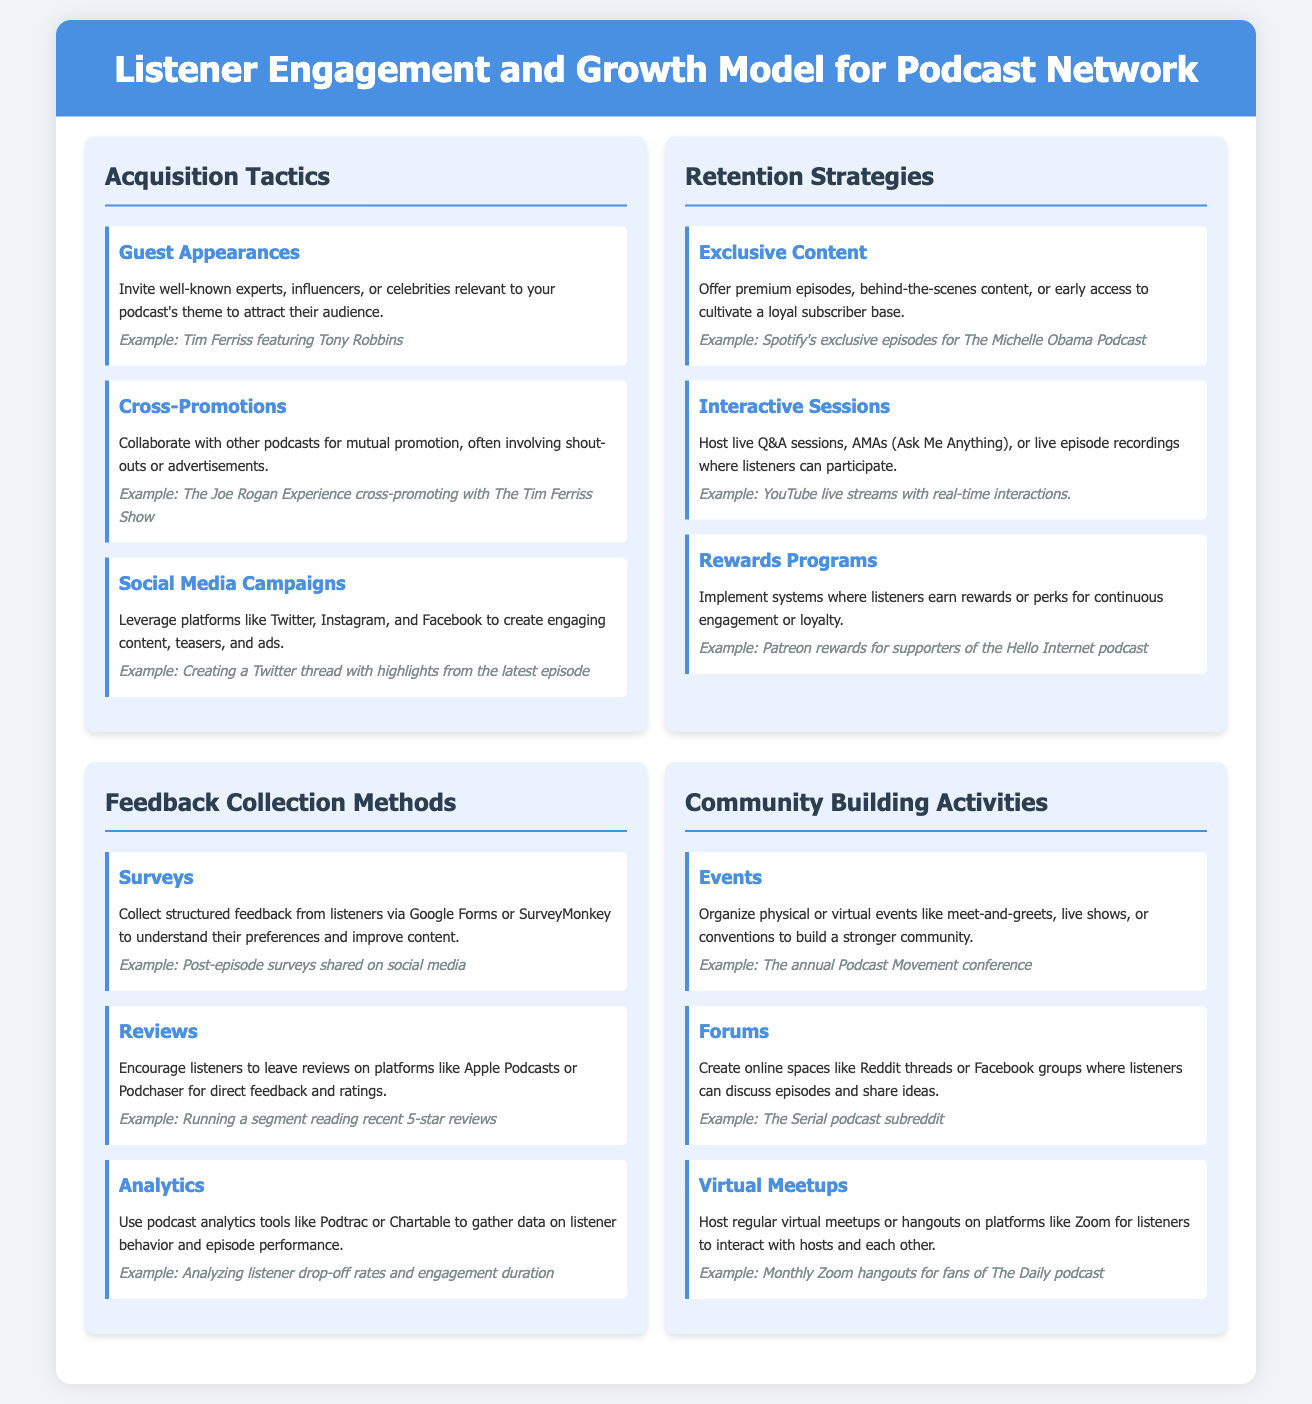What are the three acquisition tactics listed? The document lists guest appearances, cross-promotions, and social media campaigns as the three acquisition tactics.
Answer: guest appearances, cross-promotions, social media campaigns Which retention strategy involves live interactions? The strategy that involves live interactions is "Interactive Sessions."
Answer: Interactive Sessions What feedback collection method uses structured forms? The method that uses structured forms for feedback collection is "Surveys."
Answer: Surveys Name one example of a community building activity. The document mentions events, forums, and virtual meetups as community building activities; one example is "Events."
Answer: Events What is one example of exclusive content mentioned? "Premium episodes, behind-the-scenes content, or early access" are all mentioned, but one specific example mentioned is "Spotify's exclusive episodes for The Michelle Obama Podcast."
Answer: Spotify's exclusive episodes for The Michelle Obama Podcast How does the document suggest collecting feedback through reviews? The document encourages listeners to leave reviews on platforms like Apple Podcasts or Podchaser for direct feedback and ratings.
Answer: Apple's Podcasts, Podchaser What type of content does "Rewards Programs" involve? "Rewards Programs" involve systems where listeners earn rewards or perks for continuous engagement or loyalty.
Answer: Rewards or perks for continuous engagement Which acquisition tactic includes collaborations with other podcasts? The acquisition tactic that includes collaborations with other podcasts is "Cross-Promotions."
Answer: Cross-Promotions 